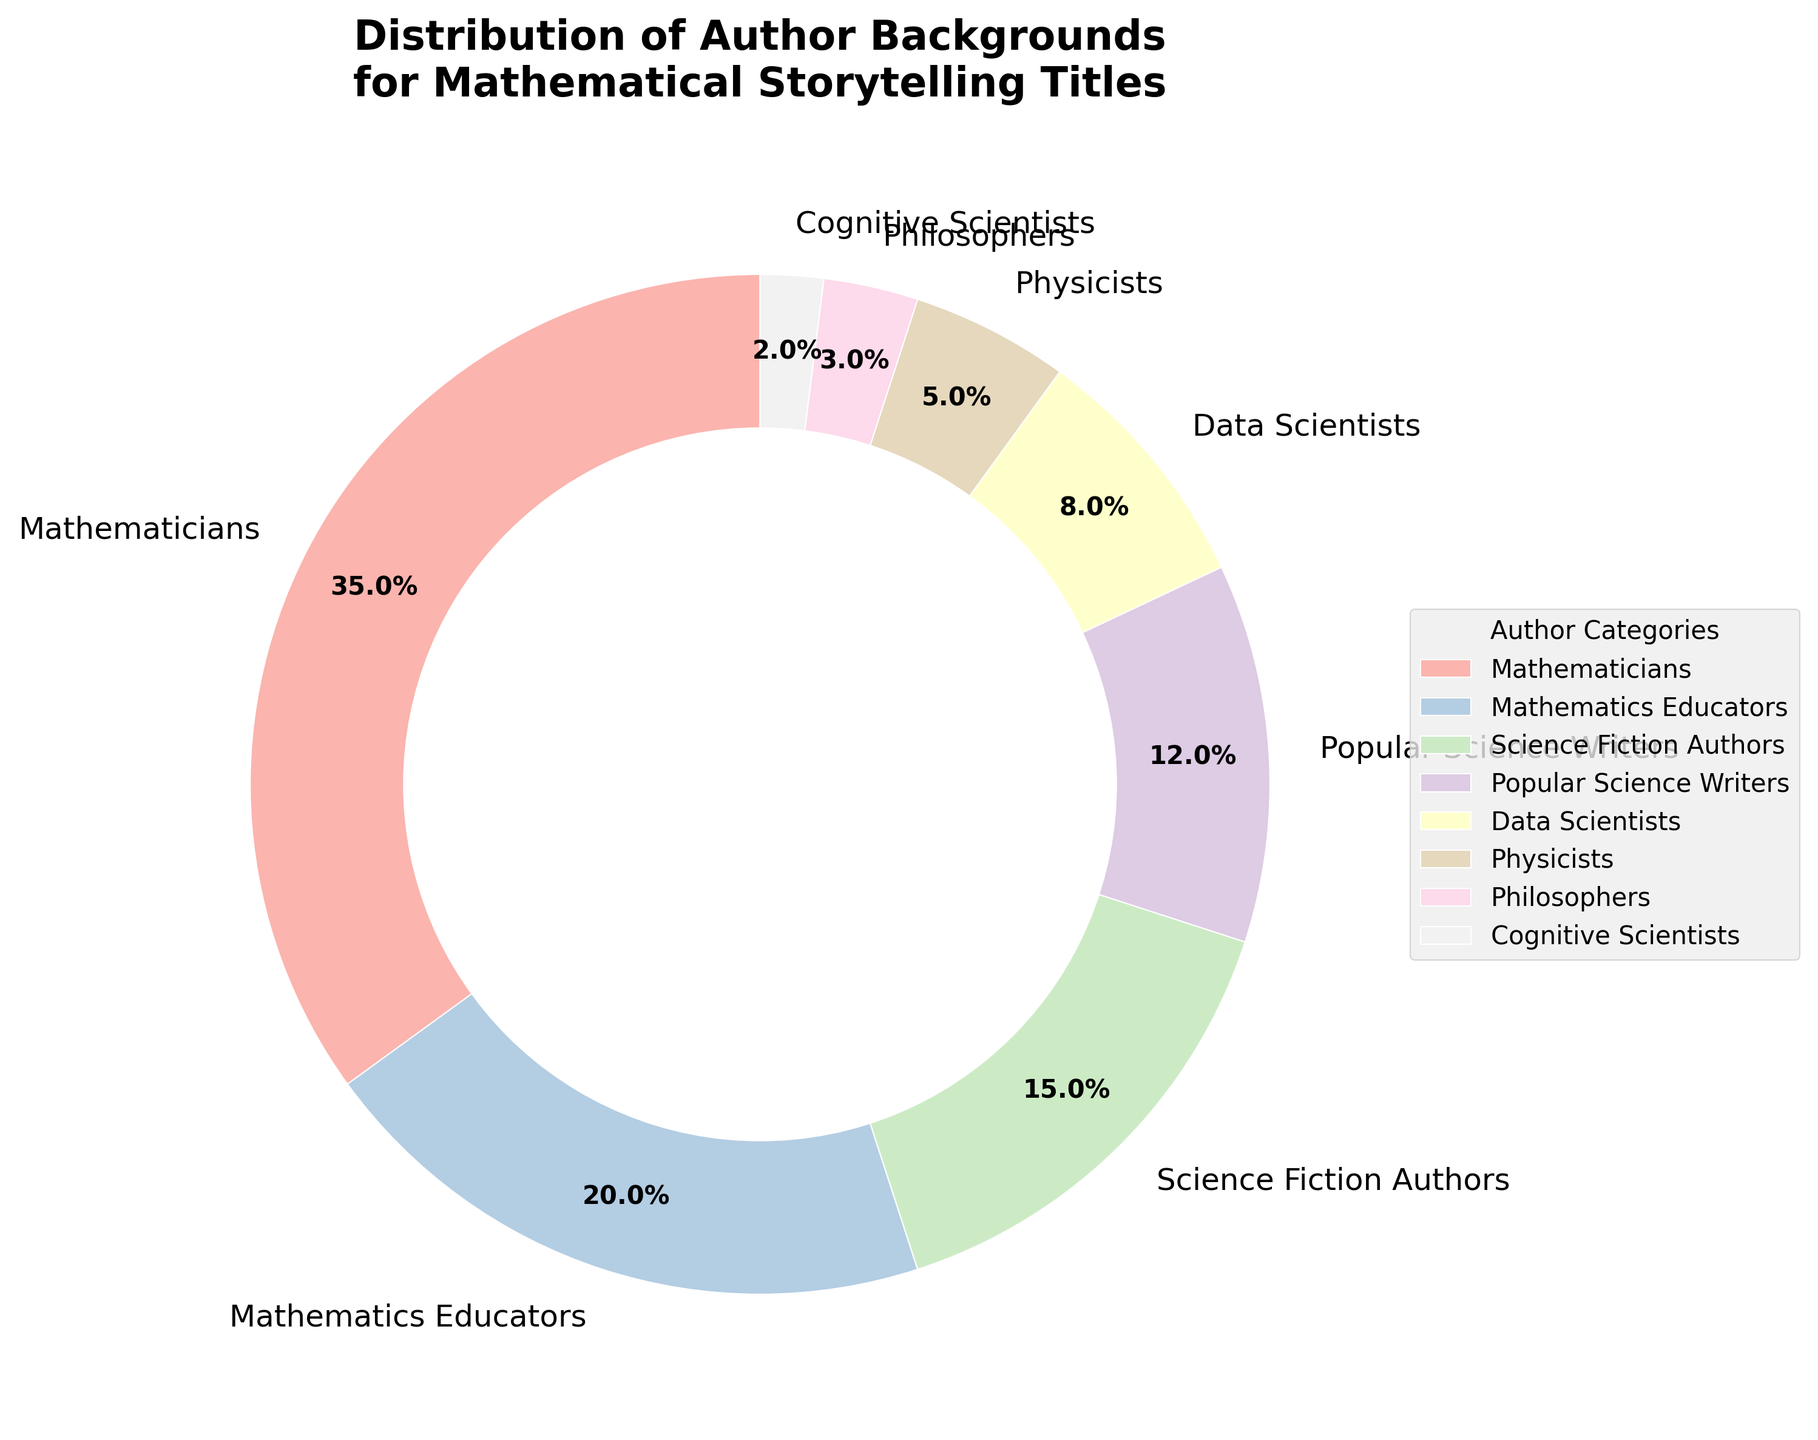Which author category has the highest percentage? By examining the pie chart, we can see that the section with the largest wedge belongs to Mathematicians.
Answer: Mathematicians Which author category accounts for the smallest percentage? By looking at the pie chart, we observe that the smallest wedge is labeled Cognitive Scientists.
Answer: Cognitive Scientists What is the combined percentage of Mathematicians and Mathematics Educators? The pie chart shows that Mathematicians account for 35% and Mathematics Educators account for 20%. Adding these two percentages gives 35% + 20% = 55%.
Answer: 55% How much greater is the percentage of Science Fiction Authors compared to Physicists? The pie chart indicates that Science Fiction Authors represent 15% while Physicists represent 5%. The difference is calculated as 15% - 5% = 10%.
Answer: 10% Which categories together make up less than 10% each? Reviewing the pie chart, Data Scientists (8%), Physicists (5%), Philosophers (3%), and Cognitive Scientists (2%) each have individual percentages less than 10%.
Answer: Data Scientists, Physicists, Philosophers, Cognitive Scientists What is the total percentage of authors who are Data Scientists, Physicists, Philosophers, and Cognitive Scientists combined? Summing the percentages from the pie chart: Data Scientists (8%) + Physicists (5%) + Philosophers (3%) + Cognitive Scientists (2%) results in 8% + 5% + 3% + 2% = 18%.
Answer: 18% How many percentage points higher are Popular Science Writers than Cognitive Scientists? According to the pie chart, Popular Science Writers are 12% and Cognitive Scientists are 2%. The difference is 12% - 2% = 10%.
Answer: 10% Which author category has a percentage closest to 10%? Examining the pie chart shows that the closest category to 10% is Data Scientists, which is 8%.
Answer: Data Scientists If you sum up the percentages of Science Fiction Authors and Popular Science Writers, which other author categories together roughly match this combined percentage? The pie chart shows Science Fiction Authors at 15% and Popular Science Writers at 12%. Their combined percentage is 15% + 12% = 27%. Mathematics Educators at 20% combined with Physicists at 5% and Cognitive Scientists at 2% yields 20% + 5% + 2% = 27%.
Answer: Mathematics Educators, Physicists, Cognitive Scientists Is there any author category that represents twice the percentage of another category? Which ones? By examining the percentages, we can see that Mathematicians at 35% is roughly twice the percentage of Mathematics Educators at 20%, and Mathematics Educators at 20% is exactly twice the percentage of Popular Science Writers at 12%.
Answer: Mathematicians and Mathematics Educators, Mathematics Educators and Popular Science Writers 